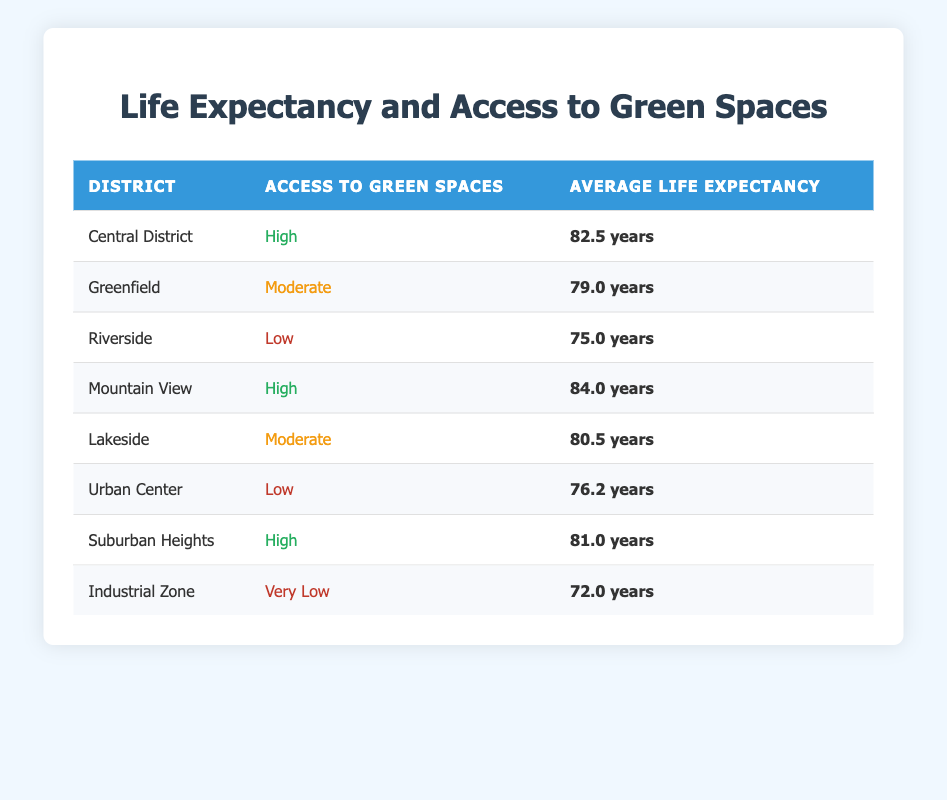What is the average life expectancy in the Central District? The table shows that the average life expectancy in the Central District is listed as 82.5 years.
Answer: 82.5 years Which district has the lowest access to green spaces, and what is its average life expectancy? According to the table, the Industrial Zone has the lowest access to green spaces categorized as "Very Low" and its average life expectancy is 72.0 years.
Answer: Industrial Zone, 72.0 years What is the difference in average life expectancy between districts with high and low access to green spaces? The districts with high access to green spaces are Central District (82.5 years), Mountain View (84.0 years), and Suburban Heights (81.0 years), averaging 82.5 years. The districts with low access are Riverside (75.0 years) and Urban Center (76.2 years), averaging 75.6 years. The difference is 82.5 - 75.6 = 6.9 years.
Answer: 6.9 years Is it true that Lakeside has a higher life expectancy than Riverside? The table indicates that Lakeside has an average life expectancy of 80.5 years, while Riverside has 75.0 years. Since 80.5 is greater than 75.0, this statement is true.
Answer: Yes What is the average life expectancy of districts with moderate access to green spaces? The districts with moderate access to green spaces are Greenfield (79.0 years) and Lakeside (80.5 years). To find the average: (79.0 + 80.5) / 2 = 79.75 years.
Answer: 79.75 years Which district has the highest average life expectancy, and what is that value? By examining the table, Mountain View has the highest average life expectancy at 84.0 years.
Answer: Mountain View, 84.0 years How many districts have an average life expectancy of over 80 years? The districts with an average life expectancy over 80 years are Central District (82.5 years), Mountain View (84.0 years), and Suburban Heights (81.0 years), totaling 3 districts.
Answer: 3 districts What is the average life expectancy across all districts listed? To calculate the average life expectancy: (82.5 + 79.0 + 75.0 + 84.0 + 80.5 + 76.2 + 81.0 + 72.0) / 8 = 78.55 years.
Answer: 78.55 years What percentage of the districts have high access to green spaces? There are 8 total districts, and 3 districts have high access (Central District, Mountain View, Suburban Heights). The percentage is (3/8) * 100 = 37.5%.
Answer: 37.5% 